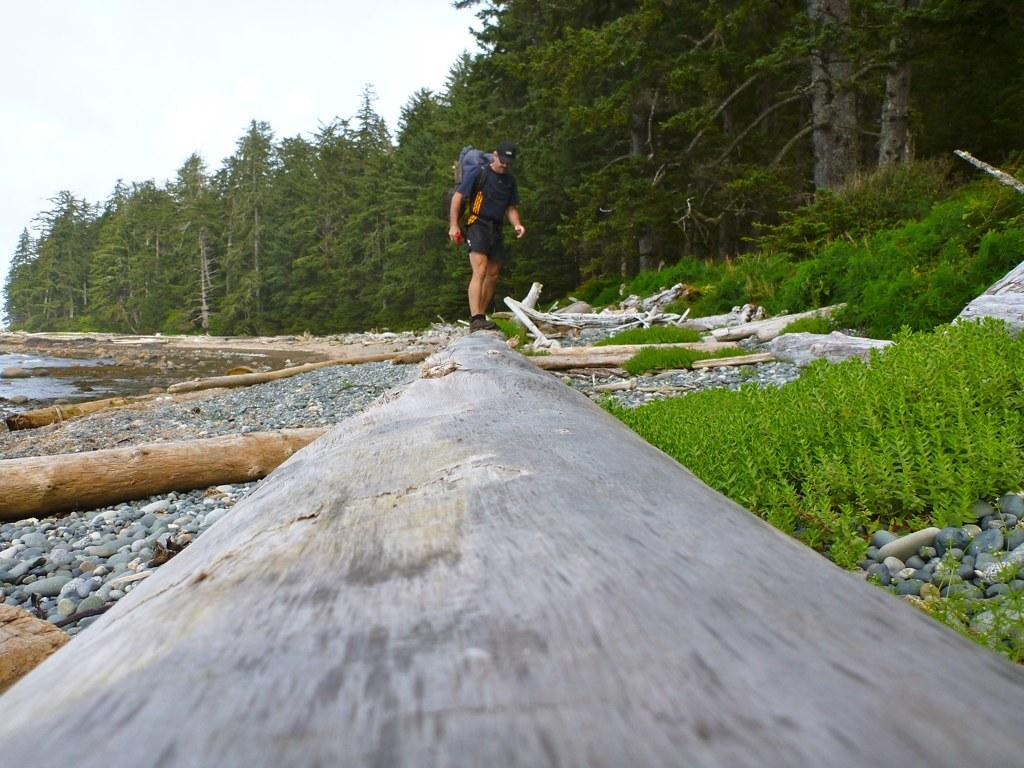What is the person in the image doing? There is a person standing in the image. What can be seen on the person's head? The person is wearing a cap. What is the person carrying in the image? The person is carrying a bag. What type of vegetation is on the right side of the image? There are trees on the right side of the image. What type of natural elements can be seen in the image? There are stones, logs of wood, and water in the image. What type of scale can be seen in the image? There is no scale present in the image. What songs is the person singing in the image? There is no indication that the person is singing in the image. 